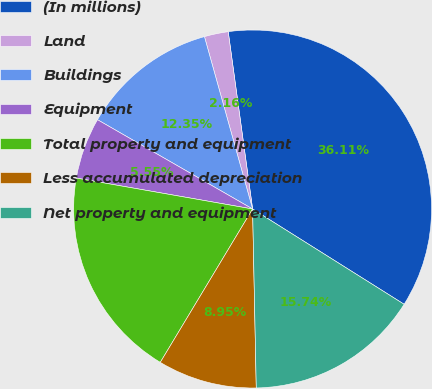Convert chart to OTSL. <chart><loc_0><loc_0><loc_500><loc_500><pie_chart><fcel>(In millions)<fcel>Land<fcel>Buildings<fcel>Equipment<fcel>Total property and equipment<fcel>Less accumulated depreciation<fcel>Net property and equipment<nl><fcel>36.11%<fcel>2.16%<fcel>12.35%<fcel>5.55%<fcel>19.14%<fcel>8.95%<fcel>15.74%<nl></chart> 